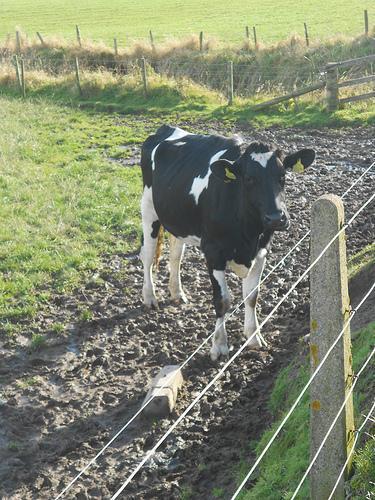How many cows are there?
Give a very brief answer. 1. How many people are pictured?
Give a very brief answer. 0. 